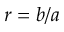Convert formula to latex. <formula><loc_0><loc_0><loc_500><loc_500>r = b / a</formula> 